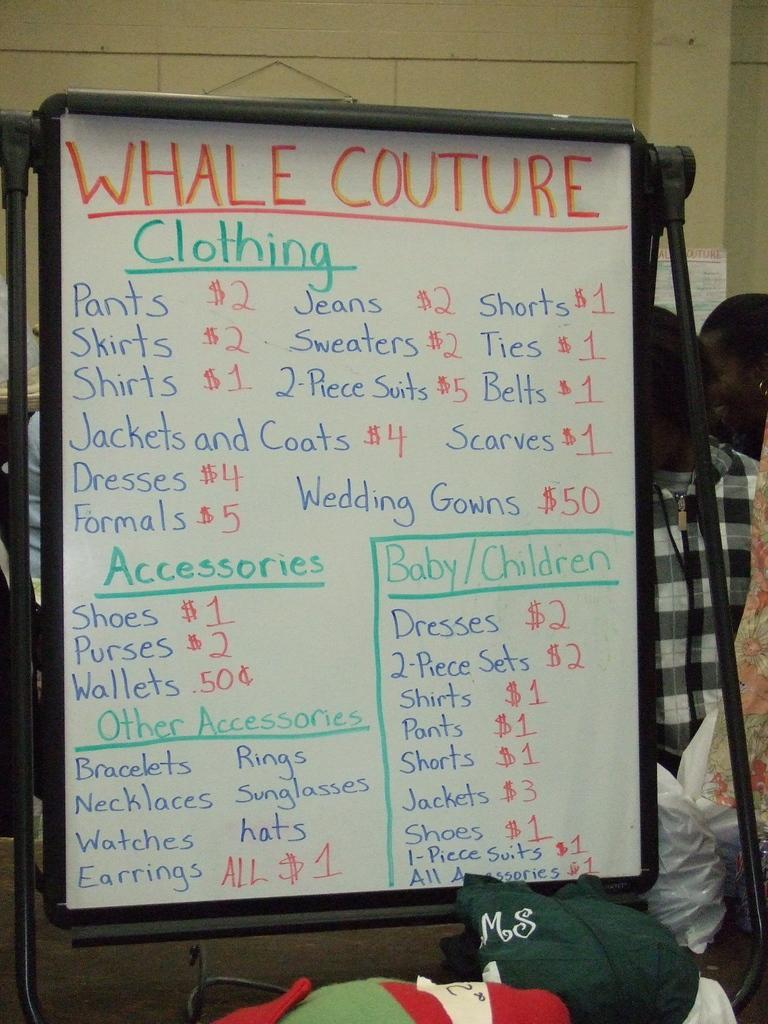What is the main object in the image? There is a board in the image. What other items can be seen in the image? There is a toy, clothes, plastic covers, and a poster in the image. How many people are present in the image? There are two people in the image. What is visible in the background of the image? There is a wall in the background of the image. What type of brick is being used to build the wall in the image? There is no information about the type of brick used to build the wall in the image. Additionally, the wall is not the main focus of the image, so it is not possible to determine the type of brick used. Is there a birthday celebration happening in the image? There is no indication of a birthday celebration in the image. 